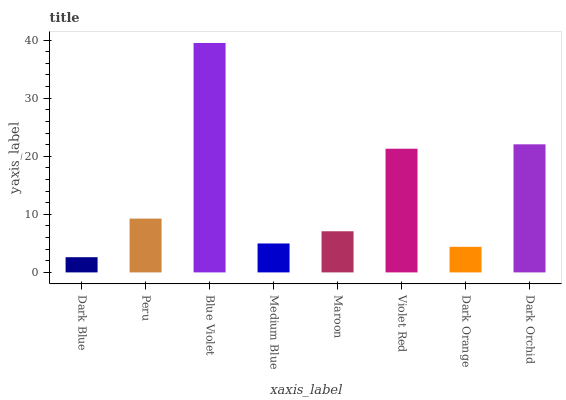Is Dark Blue the minimum?
Answer yes or no. Yes. Is Blue Violet the maximum?
Answer yes or no. Yes. Is Peru the minimum?
Answer yes or no. No. Is Peru the maximum?
Answer yes or no. No. Is Peru greater than Dark Blue?
Answer yes or no. Yes. Is Dark Blue less than Peru?
Answer yes or no. Yes. Is Dark Blue greater than Peru?
Answer yes or no. No. Is Peru less than Dark Blue?
Answer yes or no. No. Is Peru the high median?
Answer yes or no. Yes. Is Maroon the low median?
Answer yes or no. Yes. Is Maroon the high median?
Answer yes or no. No. Is Peru the low median?
Answer yes or no. No. 